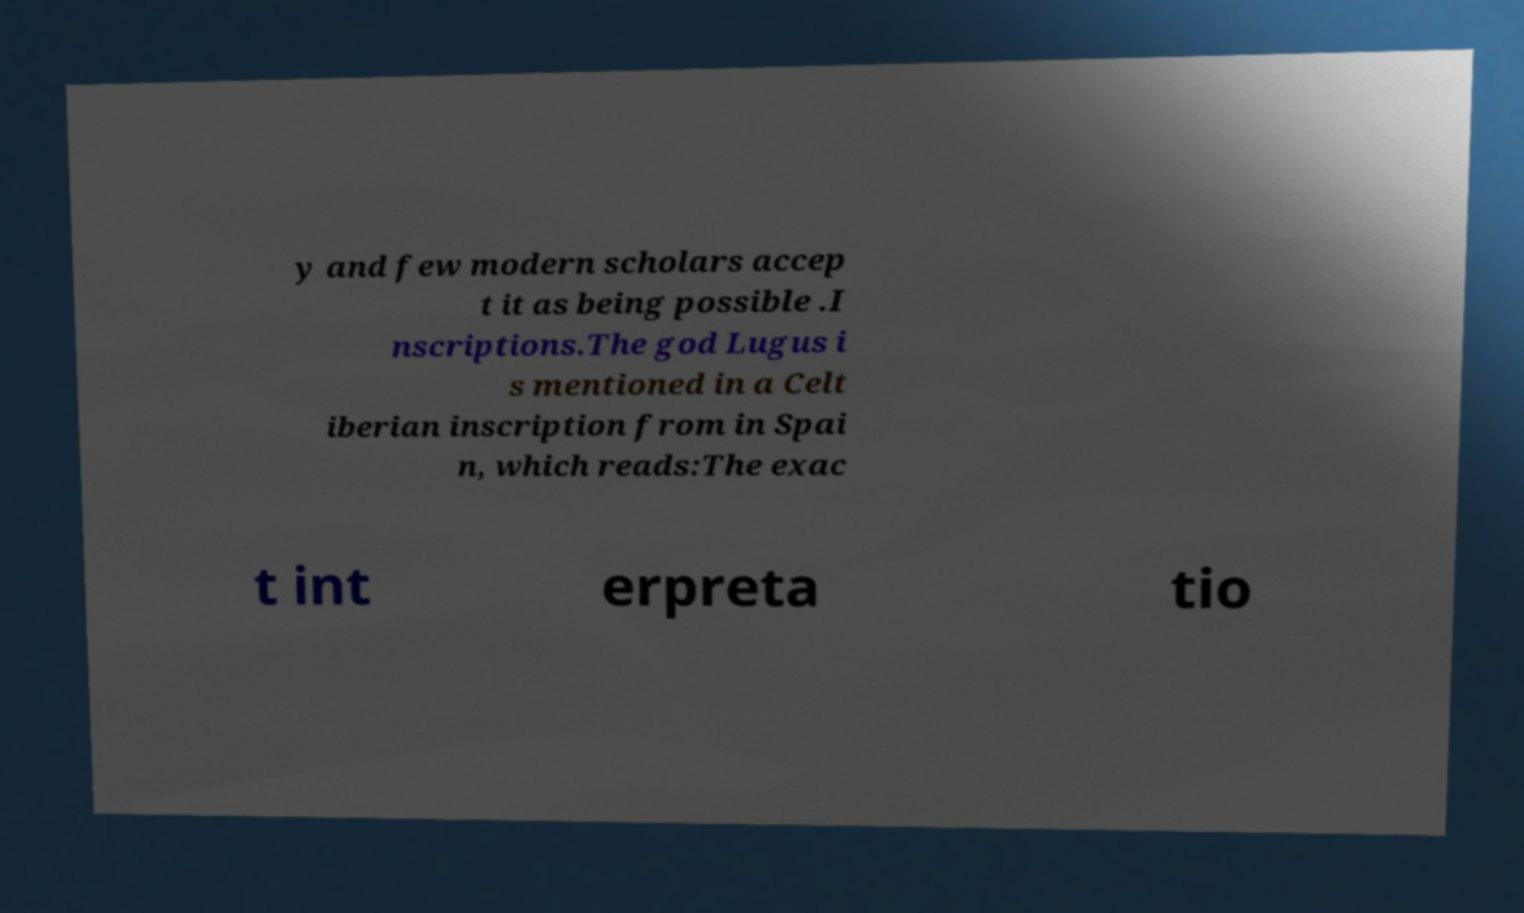For documentation purposes, I need the text within this image transcribed. Could you provide that? y and few modern scholars accep t it as being possible .I nscriptions.The god Lugus i s mentioned in a Celt iberian inscription from in Spai n, which reads:The exac t int erpreta tio 